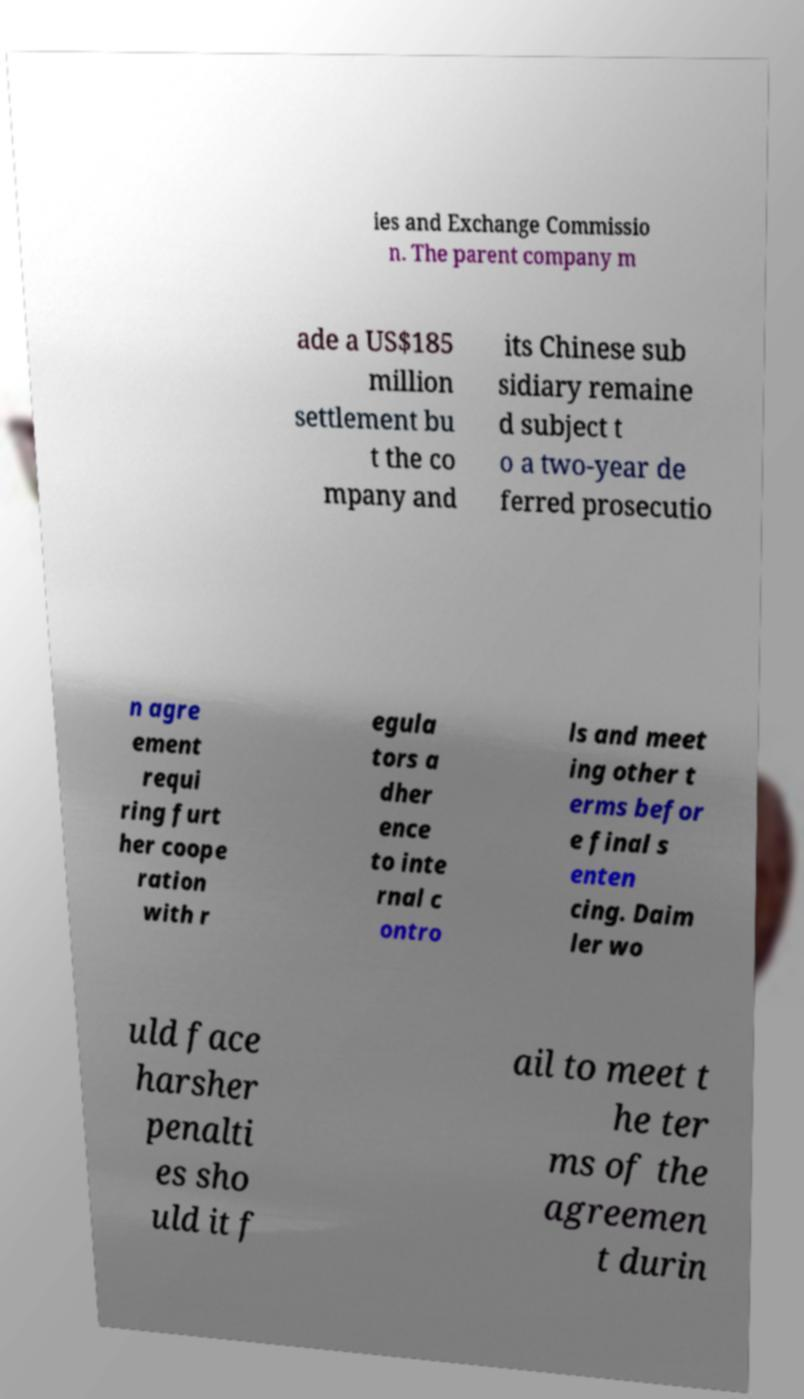Can you read and provide the text displayed in the image?This photo seems to have some interesting text. Can you extract and type it out for me? ies and Exchange Commissio n. The parent company m ade a US$185 million settlement bu t the co mpany and its Chinese sub sidiary remaine d subject t o a two-year de ferred prosecutio n agre ement requi ring furt her coope ration with r egula tors a dher ence to inte rnal c ontro ls and meet ing other t erms befor e final s enten cing. Daim ler wo uld face harsher penalti es sho uld it f ail to meet t he ter ms of the agreemen t durin 